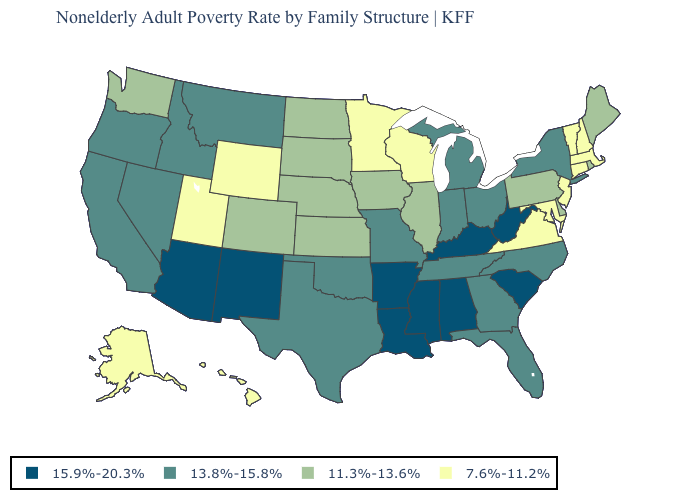What is the value of Texas?
Quick response, please. 13.8%-15.8%. What is the lowest value in the USA?
Answer briefly. 7.6%-11.2%. Which states have the lowest value in the USA?
Quick response, please. Alaska, Connecticut, Hawaii, Maryland, Massachusetts, Minnesota, New Hampshire, New Jersey, Utah, Vermont, Virginia, Wisconsin, Wyoming. What is the highest value in the USA?
Short answer required. 15.9%-20.3%. Which states have the highest value in the USA?
Keep it brief. Alabama, Arizona, Arkansas, Kentucky, Louisiana, Mississippi, New Mexico, South Carolina, West Virginia. Name the states that have a value in the range 7.6%-11.2%?
Answer briefly. Alaska, Connecticut, Hawaii, Maryland, Massachusetts, Minnesota, New Hampshire, New Jersey, Utah, Vermont, Virginia, Wisconsin, Wyoming. What is the value of Alaska?
Be succinct. 7.6%-11.2%. Name the states that have a value in the range 7.6%-11.2%?
Write a very short answer. Alaska, Connecticut, Hawaii, Maryland, Massachusetts, Minnesota, New Hampshire, New Jersey, Utah, Vermont, Virginia, Wisconsin, Wyoming. Does California have a lower value than Alaska?
Short answer required. No. How many symbols are there in the legend?
Give a very brief answer. 4. Name the states that have a value in the range 13.8%-15.8%?
Answer briefly. California, Florida, Georgia, Idaho, Indiana, Michigan, Missouri, Montana, Nevada, New York, North Carolina, Ohio, Oklahoma, Oregon, Tennessee, Texas. Which states hav the highest value in the Northeast?
Answer briefly. New York. What is the value of Minnesota?
Write a very short answer. 7.6%-11.2%. Does Oregon have a lower value than Alabama?
Concise answer only. Yes. Is the legend a continuous bar?
Quick response, please. No. 